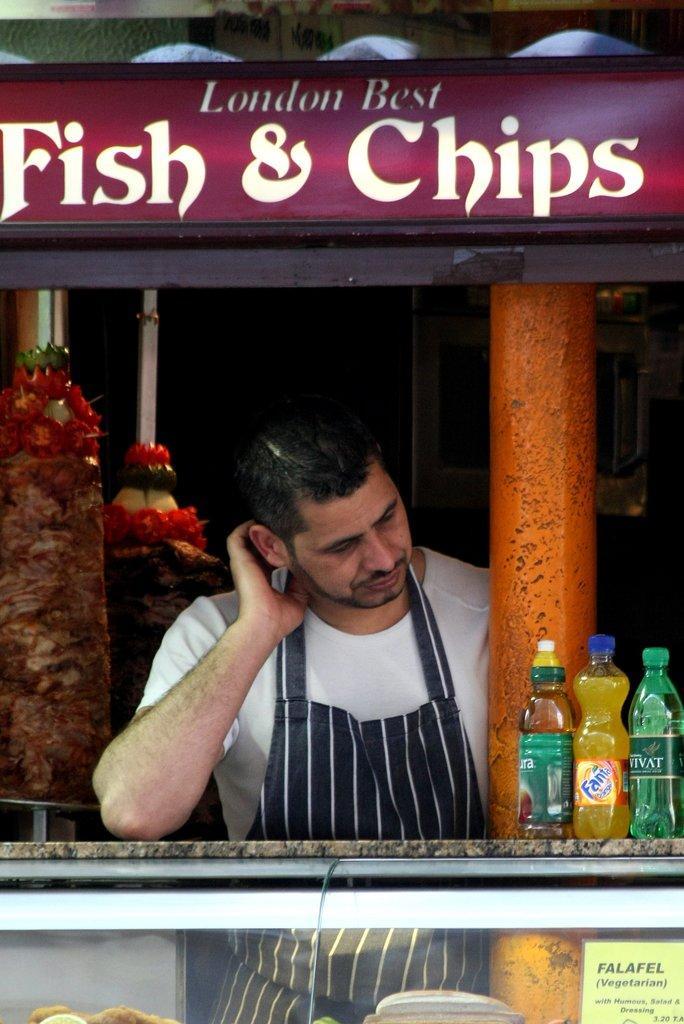How would you summarize this image in a sentence or two? This is the picture of a man in white t shirt was standing on the floor. In front the man there is a table on the table there are bottles, glass. Behind the man there are some food items to the pole. On top of the man there is a board written as a fish and chips. 